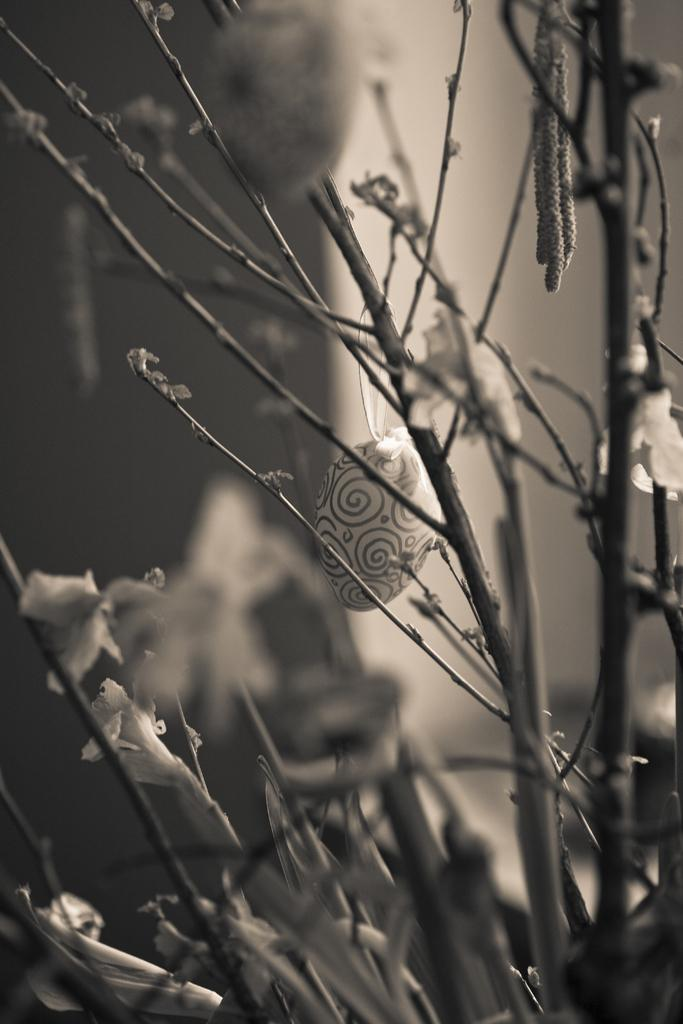What is the color scheme of the image? The image is black and white. What type of living organisms can be seen in the image? Plants are visible in the image. Can you describe the background of the image? The background of the image is blurred. What type of calendar is hanging on the wall in the image? There is no wall or calendar present in the image; it is a black and white image featuring plants with a blurred background. 